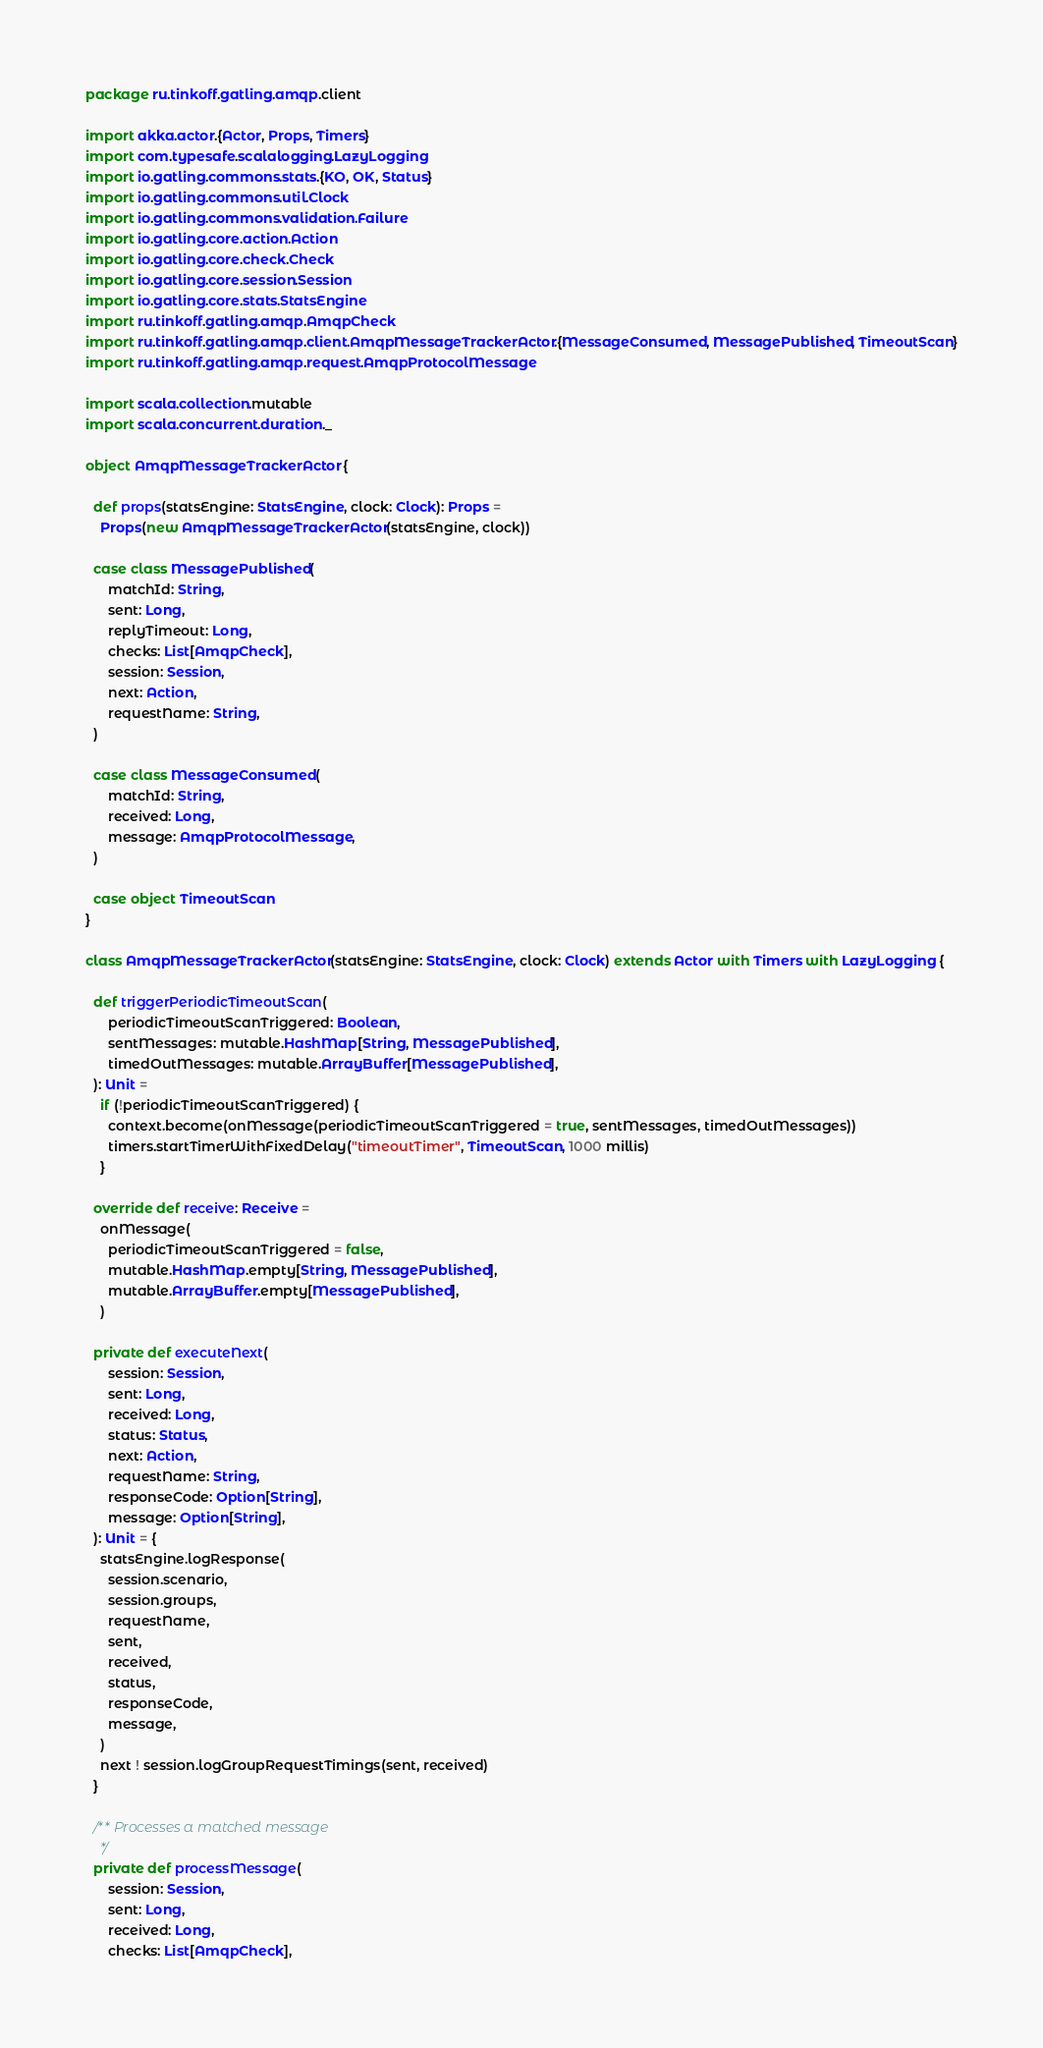Convert code to text. <code><loc_0><loc_0><loc_500><loc_500><_Scala_>package ru.tinkoff.gatling.amqp.client

import akka.actor.{Actor, Props, Timers}
import com.typesafe.scalalogging.LazyLogging
import io.gatling.commons.stats.{KO, OK, Status}
import io.gatling.commons.util.Clock
import io.gatling.commons.validation.Failure
import io.gatling.core.action.Action
import io.gatling.core.check.Check
import io.gatling.core.session.Session
import io.gatling.core.stats.StatsEngine
import ru.tinkoff.gatling.amqp.AmqpCheck
import ru.tinkoff.gatling.amqp.client.AmqpMessageTrackerActor.{MessageConsumed, MessagePublished, TimeoutScan}
import ru.tinkoff.gatling.amqp.request.AmqpProtocolMessage

import scala.collection.mutable
import scala.concurrent.duration._

object AmqpMessageTrackerActor {

  def props(statsEngine: StatsEngine, clock: Clock): Props =
    Props(new AmqpMessageTrackerActor(statsEngine, clock))

  case class MessagePublished(
      matchId: String,
      sent: Long,
      replyTimeout: Long,
      checks: List[AmqpCheck],
      session: Session,
      next: Action,
      requestName: String,
  )

  case class MessageConsumed(
      matchId: String,
      received: Long,
      message: AmqpProtocolMessage,
  )

  case object TimeoutScan
}

class AmqpMessageTrackerActor(statsEngine: StatsEngine, clock: Clock) extends Actor with Timers with LazyLogging {

  def triggerPeriodicTimeoutScan(
      periodicTimeoutScanTriggered: Boolean,
      sentMessages: mutable.HashMap[String, MessagePublished],
      timedOutMessages: mutable.ArrayBuffer[MessagePublished],
  ): Unit =
    if (!periodicTimeoutScanTriggered) {
      context.become(onMessage(periodicTimeoutScanTriggered = true, sentMessages, timedOutMessages))
      timers.startTimerWithFixedDelay("timeoutTimer", TimeoutScan, 1000 millis)
    }

  override def receive: Receive =
    onMessage(
      periodicTimeoutScanTriggered = false,
      mutable.HashMap.empty[String, MessagePublished],
      mutable.ArrayBuffer.empty[MessagePublished],
    )

  private def executeNext(
      session: Session,
      sent: Long,
      received: Long,
      status: Status,
      next: Action,
      requestName: String,
      responseCode: Option[String],
      message: Option[String],
  ): Unit = {
    statsEngine.logResponse(
      session.scenario,
      session.groups,
      requestName,
      sent,
      received,
      status,
      responseCode,
      message,
    )
    next ! session.logGroupRequestTimings(sent, received)
  }

  /** Processes a matched message
    */
  private def processMessage(
      session: Session,
      sent: Long,
      received: Long,
      checks: List[AmqpCheck],</code> 